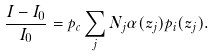<formula> <loc_0><loc_0><loc_500><loc_500>\frac { I - I _ { 0 } } { I _ { 0 } } = p _ { c } \sum _ { j } N _ { j } \alpha ( z _ { j } ) p _ { i } ( z _ { j } ) .</formula> 